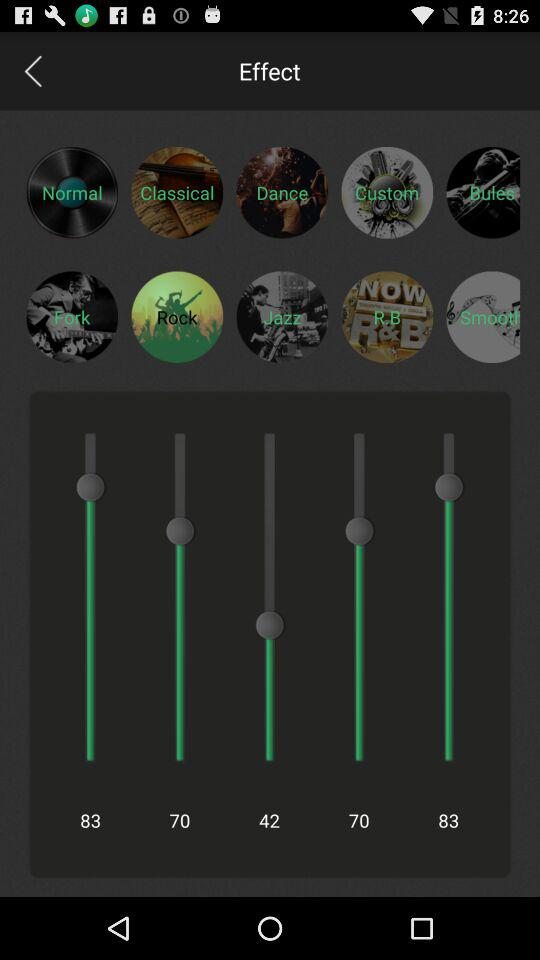What are the available effects? The available effects are Normal, Classical, Dance, Custom, Butes, Fork, Rock, Jazz, R.B and Smooth. 